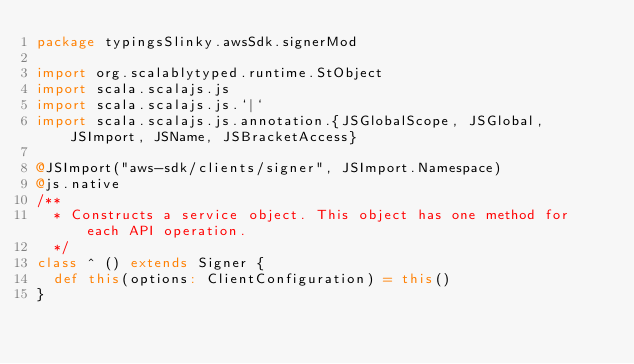<code> <loc_0><loc_0><loc_500><loc_500><_Scala_>package typingsSlinky.awsSdk.signerMod

import org.scalablytyped.runtime.StObject
import scala.scalajs.js
import scala.scalajs.js.`|`
import scala.scalajs.js.annotation.{JSGlobalScope, JSGlobal, JSImport, JSName, JSBracketAccess}

@JSImport("aws-sdk/clients/signer", JSImport.Namespace)
@js.native
/**
  * Constructs a service object. This object has one method for each API operation.
  */
class ^ () extends Signer {
  def this(options: ClientConfiguration) = this()
}
</code> 